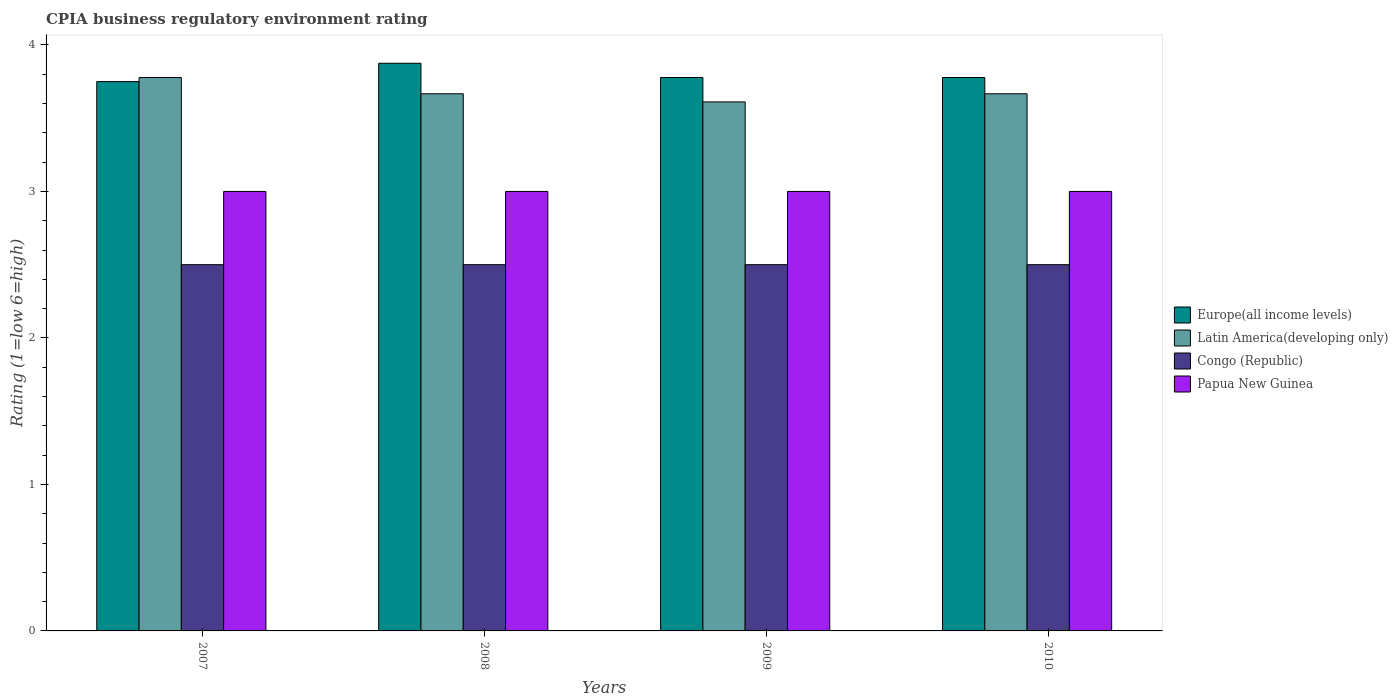Are the number of bars per tick equal to the number of legend labels?
Ensure brevity in your answer.  Yes. Are the number of bars on each tick of the X-axis equal?
Ensure brevity in your answer.  Yes. In how many cases, is the number of bars for a given year not equal to the number of legend labels?
Your answer should be very brief. 0. What is the CPIA rating in Europe(all income levels) in 2009?
Offer a terse response. 3.78. Across all years, what is the maximum CPIA rating in Europe(all income levels)?
Your answer should be very brief. 3.88. Across all years, what is the minimum CPIA rating in Papua New Guinea?
Offer a terse response. 3. What is the total CPIA rating in Congo (Republic) in the graph?
Ensure brevity in your answer.  10. What is the difference between the CPIA rating in Europe(all income levels) in 2007 and that in 2010?
Your answer should be very brief. -0.03. What is the difference between the CPIA rating in Congo (Republic) in 2007 and the CPIA rating in Latin America(developing only) in 2008?
Keep it short and to the point. -1.17. What is the average CPIA rating in Latin America(developing only) per year?
Offer a very short reply. 3.68. In the year 2007, what is the difference between the CPIA rating in Europe(all income levels) and CPIA rating in Latin America(developing only)?
Your answer should be very brief. -0.03. In how many years, is the CPIA rating in Latin America(developing only) greater than 3?
Provide a short and direct response. 4. What is the ratio of the CPIA rating in Latin America(developing only) in 2007 to that in 2009?
Keep it short and to the point. 1.05. What is the difference between the highest and the second highest CPIA rating in Europe(all income levels)?
Give a very brief answer. 0.1. Is the sum of the CPIA rating in Congo (Republic) in 2008 and 2010 greater than the maximum CPIA rating in Latin America(developing only) across all years?
Ensure brevity in your answer.  Yes. Is it the case that in every year, the sum of the CPIA rating in Papua New Guinea and CPIA rating in Latin America(developing only) is greater than the sum of CPIA rating in Congo (Republic) and CPIA rating in Europe(all income levels)?
Offer a terse response. No. What does the 1st bar from the left in 2007 represents?
Ensure brevity in your answer.  Europe(all income levels). What does the 2nd bar from the right in 2008 represents?
Provide a succinct answer. Congo (Republic). Are all the bars in the graph horizontal?
Provide a short and direct response. No. How many years are there in the graph?
Your answer should be compact. 4. Does the graph contain any zero values?
Your answer should be compact. No. Does the graph contain grids?
Offer a very short reply. No. How many legend labels are there?
Your answer should be compact. 4. What is the title of the graph?
Ensure brevity in your answer.  CPIA business regulatory environment rating. Does "Guam" appear as one of the legend labels in the graph?
Give a very brief answer. No. What is the label or title of the Y-axis?
Ensure brevity in your answer.  Rating (1=low 6=high). What is the Rating (1=low 6=high) of Europe(all income levels) in 2007?
Offer a terse response. 3.75. What is the Rating (1=low 6=high) of Latin America(developing only) in 2007?
Offer a terse response. 3.78. What is the Rating (1=low 6=high) in Congo (Republic) in 2007?
Keep it short and to the point. 2.5. What is the Rating (1=low 6=high) in Papua New Guinea in 2007?
Offer a very short reply. 3. What is the Rating (1=low 6=high) of Europe(all income levels) in 2008?
Make the answer very short. 3.88. What is the Rating (1=low 6=high) of Latin America(developing only) in 2008?
Offer a terse response. 3.67. What is the Rating (1=low 6=high) of Congo (Republic) in 2008?
Provide a short and direct response. 2.5. What is the Rating (1=low 6=high) of Papua New Guinea in 2008?
Ensure brevity in your answer.  3. What is the Rating (1=low 6=high) of Europe(all income levels) in 2009?
Offer a very short reply. 3.78. What is the Rating (1=low 6=high) of Latin America(developing only) in 2009?
Provide a short and direct response. 3.61. What is the Rating (1=low 6=high) of Europe(all income levels) in 2010?
Ensure brevity in your answer.  3.78. What is the Rating (1=low 6=high) of Latin America(developing only) in 2010?
Your response must be concise. 3.67. Across all years, what is the maximum Rating (1=low 6=high) in Europe(all income levels)?
Your response must be concise. 3.88. Across all years, what is the maximum Rating (1=low 6=high) in Latin America(developing only)?
Your answer should be compact. 3.78. Across all years, what is the maximum Rating (1=low 6=high) in Congo (Republic)?
Offer a very short reply. 2.5. Across all years, what is the maximum Rating (1=low 6=high) of Papua New Guinea?
Your answer should be compact. 3. Across all years, what is the minimum Rating (1=low 6=high) in Europe(all income levels)?
Your response must be concise. 3.75. Across all years, what is the minimum Rating (1=low 6=high) in Latin America(developing only)?
Make the answer very short. 3.61. Across all years, what is the minimum Rating (1=low 6=high) in Congo (Republic)?
Give a very brief answer. 2.5. Across all years, what is the minimum Rating (1=low 6=high) of Papua New Guinea?
Provide a short and direct response. 3. What is the total Rating (1=low 6=high) in Europe(all income levels) in the graph?
Give a very brief answer. 15.18. What is the total Rating (1=low 6=high) of Latin America(developing only) in the graph?
Provide a short and direct response. 14.72. What is the total Rating (1=low 6=high) in Congo (Republic) in the graph?
Offer a terse response. 10. What is the total Rating (1=low 6=high) in Papua New Guinea in the graph?
Ensure brevity in your answer.  12. What is the difference between the Rating (1=low 6=high) in Europe(all income levels) in 2007 and that in 2008?
Offer a very short reply. -0.12. What is the difference between the Rating (1=low 6=high) of Latin America(developing only) in 2007 and that in 2008?
Keep it short and to the point. 0.11. What is the difference between the Rating (1=low 6=high) in Europe(all income levels) in 2007 and that in 2009?
Offer a terse response. -0.03. What is the difference between the Rating (1=low 6=high) in Europe(all income levels) in 2007 and that in 2010?
Offer a very short reply. -0.03. What is the difference between the Rating (1=low 6=high) of Congo (Republic) in 2007 and that in 2010?
Ensure brevity in your answer.  0. What is the difference between the Rating (1=low 6=high) in Papua New Guinea in 2007 and that in 2010?
Keep it short and to the point. 0. What is the difference between the Rating (1=low 6=high) of Europe(all income levels) in 2008 and that in 2009?
Make the answer very short. 0.1. What is the difference between the Rating (1=low 6=high) of Latin America(developing only) in 2008 and that in 2009?
Give a very brief answer. 0.06. What is the difference between the Rating (1=low 6=high) in Europe(all income levels) in 2008 and that in 2010?
Your answer should be compact. 0.1. What is the difference between the Rating (1=low 6=high) of Europe(all income levels) in 2009 and that in 2010?
Provide a succinct answer. 0. What is the difference between the Rating (1=low 6=high) of Latin America(developing only) in 2009 and that in 2010?
Your answer should be compact. -0.06. What is the difference between the Rating (1=low 6=high) of Congo (Republic) in 2009 and that in 2010?
Your answer should be very brief. 0. What is the difference between the Rating (1=low 6=high) in Europe(all income levels) in 2007 and the Rating (1=low 6=high) in Latin America(developing only) in 2008?
Provide a short and direct response. 0.08. What is the difference between the Rating (1=low 6=high) of Europe(all income levels) in 2007 and the Rating (1=low 6=high) of Congo (Republic) in 2008?
Make the answer very short. 1.25. What is the difference between the Rating (1=low 6=high) of Latin America(developing only) in 2007 and the Rating (1=low 6=high) of Congo (Republic) in 2008?
Give a very brief answer. 1.28. What is the difference between the Rating (1=low 6=high) of Congo (Republic) in 2007 and the Rating (1=low 6=high) of Papua New Guinea in 2008?
Your answer should be compact. -0.5. What is the difference between the Rating (1=low 6=high) in Europe(all income levels) in 2007 and the Rating (1=low 6=high) in Latin America(developing only) in 2009?
Keep it short and to the point. 0.14. What is the difference between the Rating (1=low 6=high) of Europe(all income levels) in 2007 and the Rating (1=low 6=high) of Papua New Guinea in 2009?
Ensure brevity in your answer.  0.75. What is the difference between the Rating (1=low 6=high) in Latin America(developing only) in 2007 and the Rating (1=low 6=high) in Congo (Republic) in 2009?
Make the answer very short. 1.28. What is the difference between the Rating (1=low 6=high) in Europe(all income levels) in 2007 and the Rating (1=low 6=high) in Latin America(developing only) in 2010?
Provide a succinct answer. 0.08. What is the difference between the Rating (1=low 6=high) in Latin America(developing only) in 2007 and the Rating (1=low 6=high) in Congo (Republic) in 2010?
Give a very brief answer. 1.28. What is the difference between the Rating (1=low 6=high) in Latin America(developing only) in 2007 and the Rating (1=low 6=high) in Papua New Guinea in 2010?
Ensure brevity in your answer.  0.78. What is the difference between the Rating (1=low 6=high) of Europe(all income levels) in 2008 and the Rating (1=low 6=high) of Latin America(developing only) in 2009?
Your response must be concise. 0.26. What is the difference between the Rating (1=low 6=high) of Europe(all income levels) in 2008 and the Rating (1=low 6=high) of Congo (Republic) in 2009?
Keep it short and to the point. 1.38. What is the difference between the Rating (1=low 6=high) of Latin America(developing only) in 2008 and the Rating (1=low 6=high) of Congo (Republic) in 2009?
Provide a short and direct response. 1.17. What is the difference between the Rating (1=low 6=high) in Latin America(developing only) in 2008 and the Rating (1=low 6=high) in Papua New Guinea in 2009?
Your response must be concise. 0.67. What is the difference between the Rating (1=low 6=high) of Europe(all income levels) in 2008 and the Rating (1=low 6=high) of Latin America(developing only) in 2010?
Offer a terse response. 0.21. What is the difference between the Rating (1=low 6=high) of Europe(all income levels) in 2008 and the Rating (1=low 6=high) of Congo (Republic) in 2010?
Offer a very short reply. 1.38. What is the difference between the Rating (1=low 6=high) of Europe(all income levels) in 2008 and the Rating (1=low 6=high) of Papua New Guinea in 2010?
Your response must be concise. 0.88. What is the difference between the Rating (1=low 6=high) in Latin America(developing only) in 2008 and the Rating (1=low 6=high) in Papua New Guinea in 2010?
Provide a short and direct response. 0.67. What is the difference between the Rating (1=low 6=high) in Europe(all income levels) in 2009 and the Rating (1=low 6=high) in Congo (Republic) in 2010?
Keep it short and to the point. 1.28. What is the difference between the Rating (1=low 6=high) in Europe(all income levels) in 2009 and the Rating (1=low 6=high) in Papua New Guinea in 2010?
Your answer should be very brief. 0.78. What is the difference between the Rating (1=low 6=high) in Latin America(developing only) in 2009 and the Rating (1=low 6=high) in Papua New Guinea in 2010?
Make the answer very short. 0.61. What is the average Rating (1=low 6=high) of Europe(all income levels) per year?
Offer a very short reply. 3.8. What is the average Rating (1=low 6=high) in Latin America(developing only) per year?
Ensure brevity in your answer.  3.68. In the year 2007, what is the difference between the Rating (1=low 6=high) of Europe(all income levels) and Rating (1=low 6=high) of Latin America(developing only)?
Provide a short and direct response. -0.03. In the year 2007, what is the difference between the Rating (1=low 6=high) in Latin America(developing only) and Rating (1=low 6=high) in Congo (Republic)?
Offer a terse response. 1.28. In the year 2007, what is the difference between the Rating (1=low 6=high) in Latin America(developing only) and Rating (1=low 6=high) in Papua New Guinea?
Your answer should be very brief. 0.78. In the year 2008, what is the difference between the Rating (1=low 6=high) in Europe(all income levels) and Rating (1=low 6=high) in Latin America(developing only)?
Provide a succinct answer. 0.21. In the year 2008, what is the difference between the Rating (1=low 6=high) of Europe(all income levels) and Rating (1=low 6=high) of Congo (Republic)?
Provide a short and direct response. 1.38. In the year 2008, what is the difference between the Rating (1=low 6=high) in Europe(all income levels) and Rating (1=low 6=high) in Papua New Guinea?
Give a very brief answer. 0.88. In the year 2008, what is the difference between the Rating (1=low 6=high) in Congo (Republic) and Rating (1=low 6=high) in Papua New Guinea?
Keep it short and to the point. -0.5. In the year 2009, what is the difference between the Rating (1=low 6=high) in Europe(all income levels) and Rating (1=low 6=high) in Congo (Republic)?
Give a very brief answer. 1.28. In the year 2009, what is the difference between the Rating (1=low 6=high) of Europe(all income levels) and Rating (1=low 6=high) of Papua New Guinea?
Offer a terse response. 0.78. In the year 2009, what is the difference between the Rating (1=low 6=high) of Latin America(developing only) and Rating (1=low 6=high) of Congo (Republic)?
Offer a very short reply. 1.11. In the year 2009, what is the difference between the Rating (1=low 6=high) in Latin America(developing only) and Rating (1=low 6=high) in Papua New Guinea?
Your response must be concise. 0.61. In the year 2010, what is the difference between the Rating (1=low 6=high) in Europe(all income levels) and Rating (1=low 6=high) in Congo (Republic)?
Your response must be concise. 1.28. What is the ratio of the Rating (1=low 6=high) of Latin America(developing only) in 2007 to that in 2008?
Make the answer very short. 1.03. What is the ratio of the Rating (1=low 6=high) of Europe(all income levels) in 2007 to that in 2009?
Give a very brief answer. 0.99. What is the ratio of the Rating (1=low 6=high) of Latin America(developing only) in 2007 to that in 2009?
Ensure brevity in your answer.  1.05. What is the ratio of the Rating (1=low 6=high) of Latin America(developing only) in 2007 to that in 2010?
Provide a short and direct response. 1.03. What is the ratio of the Rating (1=low 6=high) of Congo (Republic) in 2007 to that in 2010?
Your response must be concise. 1. What is the ratio of the Rating (1=low 6=high) of Papua New Guinea in 2007 to that in 2010?
Your answer should be compact. 1. What is the ratio of the Rating (1=low 6=high) in Europe(all income levels) in 2008 to that in 2009?
Provide a short and direct response. 1.03. What is the ratio of the Rating (1=low 6=high) in Latin America(developing only) in 2008 to that in 2009?
Ensure brevity in your answer.  1.02. What is the ratio of the Rating (1=low 6=high) of Congo (Republic) in 2008 to that in 2009?
Your answer should be compact. 1. What is the ratio of the Rating (1=low 6=high) of Europe(all income levels) in 2008 to that in 2010?
Provide a succinct answer. 1.03. What is the ratio of the Rating (1=low 6=high) in Latin America(developing only) in 2008 to that in 2010?
Keep it short and to the point. 1. What is the ratio of the Rating (1=low 6=high) of Papua New Guinea in 2008 to that in 2010?
Your answer should be very brief. 1. What is the ratio of the Rating (1=low 6=high) in Europe(all income levels) in 2009 to that in 2010?
Offer a very short reply. 1. What is the difference between the highest and the second highest Rating (1=low 6=high) in Europe(all income levels)?
Keep it short and to the point. 0.1. What is the difference between the highest and the second highest Rating (1=low 6=high) of Papua New Guinea?
Provide a short and direct response. 0. What is the difference between the highest and the lowest Rating (1=low 6=high) of Europe(all income levels)?
Give a very brief answer. 0.12. What is the difference between the highest and the lowest Rating (1=low 6=high) of Latin America(developing only)?
Provide a short and direct response. 0.17. What is the difference between the highest and the lowest Rating (1=low 6=high) in Papua New Guinea?
Your answer should be very brief. 0. 